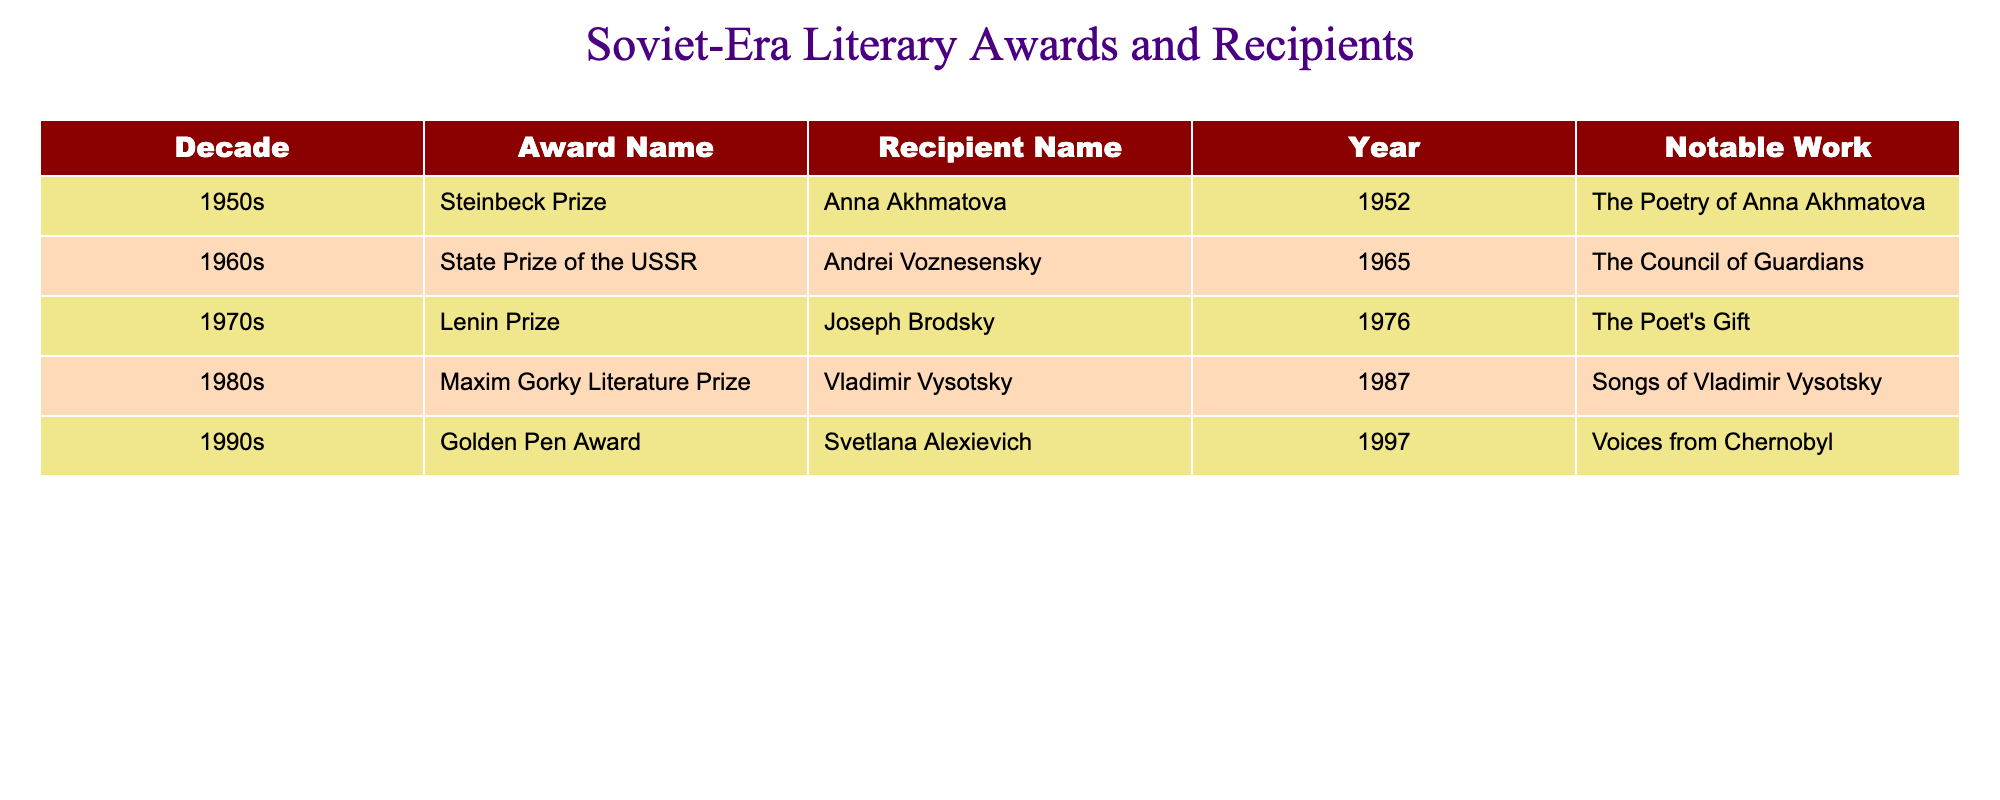What award did Anna Akhmatova receive? The table lists Anna Akhmatova as a recipient of the Steinbeck Prize in the 1950s, specifically in 1952.
Answer: Steinbeck Prize Which recipient won the State Prize of the USSR? According to the table, Andrei Voznesensky is identified as the recipient of the State Prize of the USSR in 1965.
Answer: Andrei Voznesensky How many awards were given out in the 1980s? From the table, there is one award mentioned in the 1980s, which is the Maxim Gorky Literature Prize given to Vladimir Vysotsky in 1987.
Answer: 1 Did Joseph Brodsky win any awards in the 1970s? Yes, the table clearly states that Joseph Brodsky won the Lenin Prize in 1976, which is during the 1970s.
Answer: Yes Which decade had the Golden Pen Award recipient? The table indicates that the Golden Pen Award was given to Svetlana Alexievich in the 1990s, specifically in 1997.
Answer: 1990s What is the notable work associated with the award received by Vladimir Vysotsky? The table shows that the notable work associated with the Maxim Gorky Literature Prize received by Vladimir Vysotsky in 1987 is "Songs of Vladimir Vysotsky."
Answer: Songs of Vladimir Vysotsky How many of the listed recipients were awarded in the 1960s or later? Analyzing the table, Andrei Voznesensky, Joseph Brodsky, Vladimir Vysotsky, and Svetlana Alexievich received awards in the 1960s or later, making a total of four recipients.
Answer: 4 What is the difference in years between the awards won by Anna Akhmatova and Svetlana Alexievich? The Steinbeck Prize was awarded to Anna Akhmatova in 1952, while the Golden Pen Award was given to Svetlana Alexievich in 1997. The difference in years is 1997 - 1952 = 45 years.
Answer: 45 years Was the State Prize of the USSR awarded in the 1950s? The table shows that the State Prize of the USSR was awarded to Andrei Voznesensky in 1965, which is not in the 1950s.
Answer: No Which of the listed awards was given to a recipient for their work related to Chernobyl? The table indicates that the Golden Pen Award was given to Svetlana Alexievich for her notable work "Voices from Chernobyl" in 1997.
Answer: Golden Pen Award 